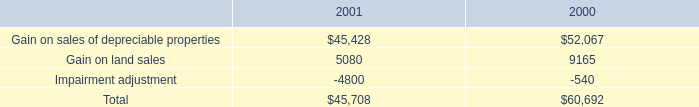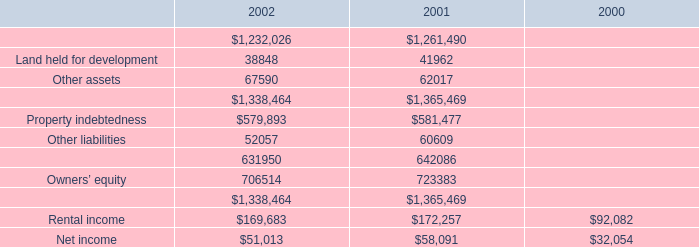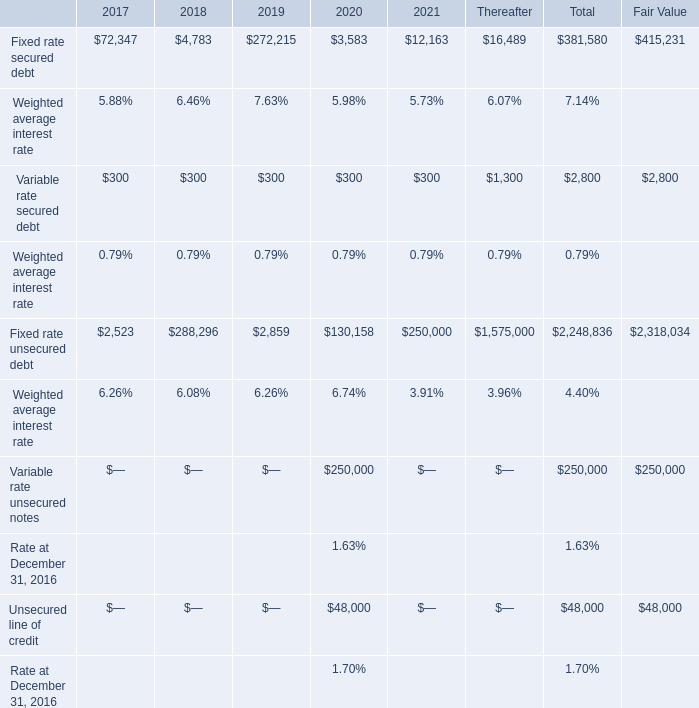What's the sum of Gain on sales of depreciable properties of 2000, and Property indebtedness of 2001 ? 
Computations: (52067.0 + 581477.0)
Answer: 633544.0. 